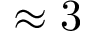<formula> <loc_0><loc_0><loc_500><loc_500>\approx 3</formula> 